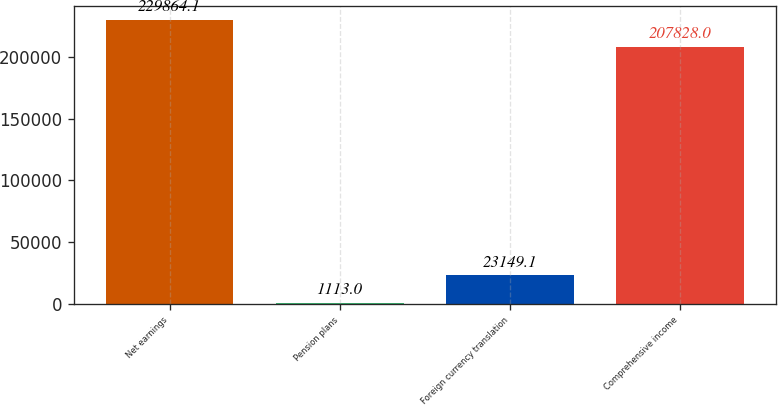Convert chart to OTSL. <chart><loc_0><loc_0><loc_500><loc_500><bar_chart><fcel>Net earnings<fcel>Pension plans<fcel>Foreign currency translation<fcel>Comprehensive income<nl><fcel>229864<fcel>1113<fcel>23149.1<fcel>207828<nl></chart> 